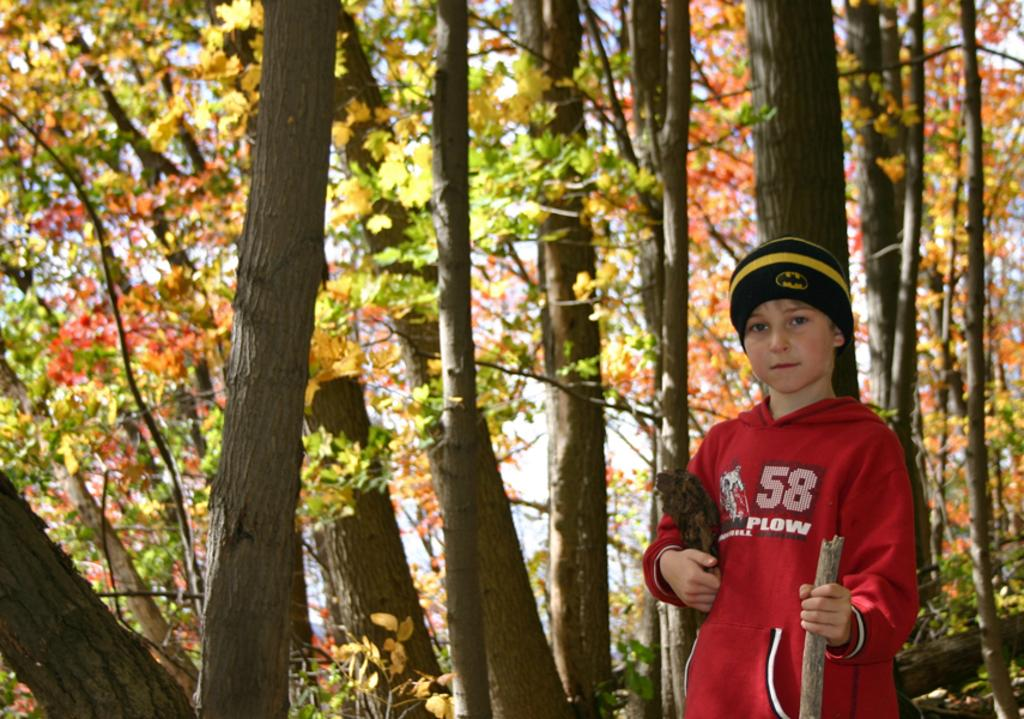<image>
Summarize the visual content of the image. a boy in a red hoodie with the number 58 standing in a forest 